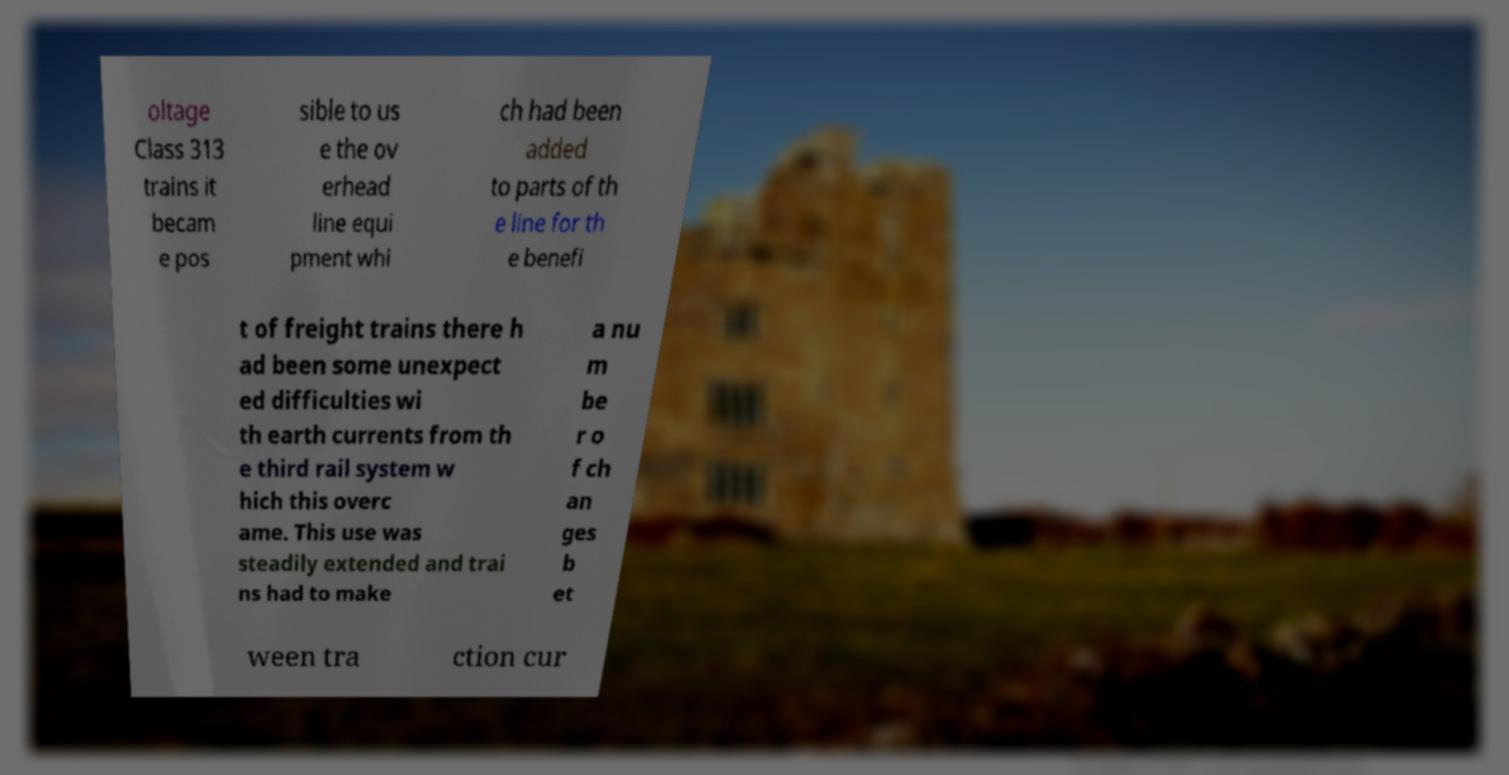Can you accurately transcribe the text from the provided image for me? oltage Class 313 trains it becam e pos sible to us e the ov erhead line equi pment whi ch had been added to parts of th e line for th e benefi t of freight trains there h ad been some unexpect ed difficulties wi th earth currents from th e third rail system w hich this overc ame. This use was steadily extended and trai ns had to make a nu m be r o f ch an ges b et ween tra ction cur 